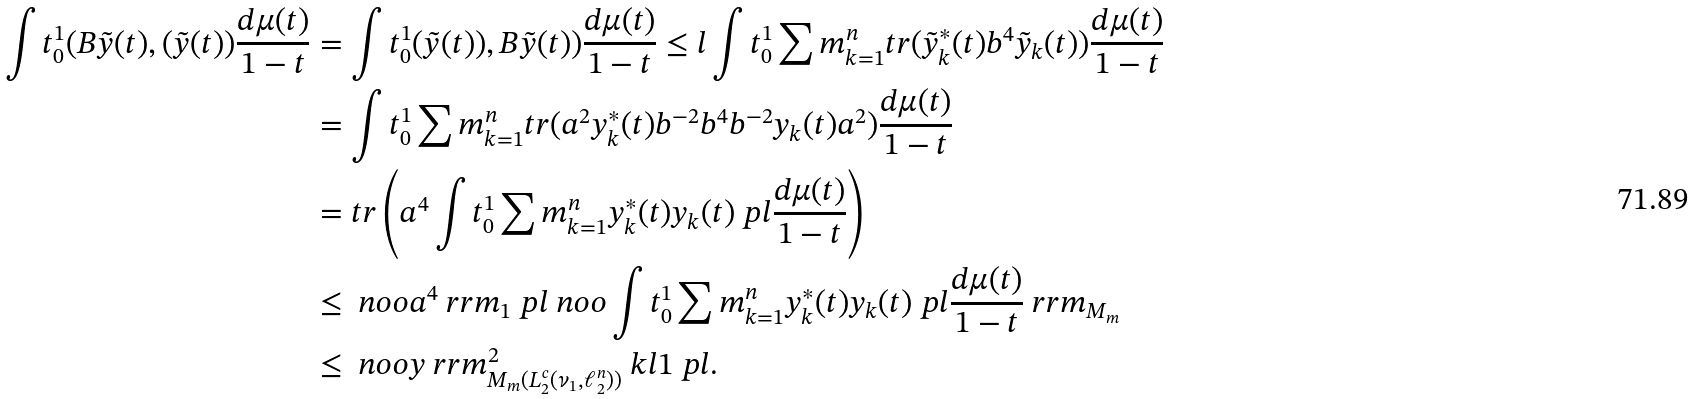Convert formula to latex. <formula><loc_0><loc_0><loc_500><loc_500>\int t _ { 0 } ^ { 1 } ( B \tilde { y } ( t ) , ( \tilde { y } ( t ) ) \frac { d \mu ( t ) } { 1 - t } & = \int t _ { 0 } ^ { 1 } ( \tilde { y } ( t ) ) , B \tilde { y } ( t ) ) \frac { d \mu ( t ) } { 1 - t } \leq l \int t _ { 0 } ^ { 1 } \sum m _ { k = 1 } ^ { n } t r ( \tilde { y } _ { k } ^ { * } ( t ) b ^ { 4 } \tilde { y } _ { k } ( t ) ) \frac { d \mu ( t ) } { 1 - t } \\ & = \int t _ { 0 } ^ { 1 } \sum m _ { k = 1 } ^ { n } t r ( a ^ { 2 } y _ { k } ^ { * } ( t ) b ^ { - 2 } b ^ { 4 } b ^ { - 2 } y _ { k } ( t ) a ^ { 2 } ) \frac { d \mu ( t ) } { 1 - t } \\ & = t r \left ( a ^ { 4 } \int t _ { 0 } ^ { 1 } \sum m _ { k = 1 } ^ { n } y _ { k } ^ { * } ( t ) y _ { k } ( t ) \ p l \frac { d \mu ( t ) } { 1 - t } \right ) \\ & \leq \ n o o a ^ { 4 } \ r r m _ { 1 } \ p l \ n o o \int t _ { 0 } ^ { 1 } \sum m _ { k = 1 } ^ { n } y _ { k } ^ { * } ( t ) y _ { k } ( t ) \ p l \frac { d \mu ( t ) } { 1 - t } \ r r m _ { M _ { m } } \\ & \leq \ n o o y \ r r m _ { M _ { m } ( L _ { 2 } ^ { c } ( \nu _ { 1 } , \ell _ { 2 } ^ { n } ) ) } ^ { 2 } \ k l 1 \ p l .</formula> 